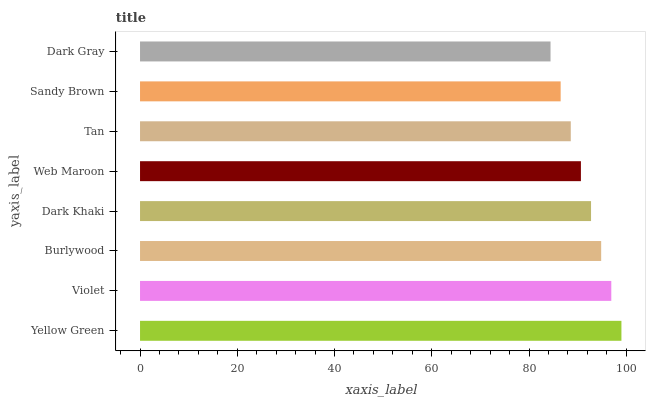Is Dark Gray the minimum?
Answer yes or no. Yes. Is Yellow Green the maximum?
Answer yes or no. Yes. Is Violet the minimum?
Answer yes or no. No. Is Violet the maximum?
Answer yes or no. No. Is Yellow Green greater than Violet?
Answer yes or no. Yes. Is Violet less than Yellow Green?
Answer yes or no. Yes. Is Violet greater than Yellow Green?
Answer yes or no. No. Is Yellow Green less than Violet?
Answer yes or no. No. Is Dark Khaki the high median?
Answer yes or no. Yes. Is Web Maroon the low median?
Answer yes or no. Yes. Is Sandy Brown the high median?
Answer yes or no. No. Is Violet the low median?
Answer yes or no. No. 